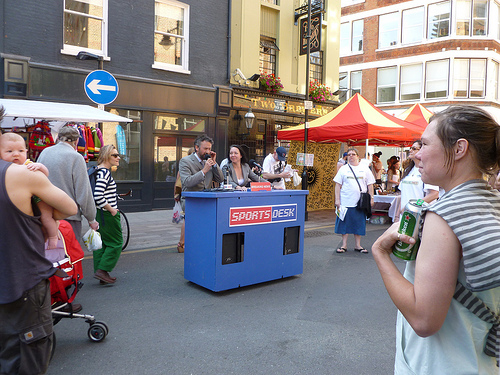<image>
Can you confirm if the umbrella is above the fat man? No. The umbrella is not positioned above the fat man. The vertical arrangement shows a different relationship. 